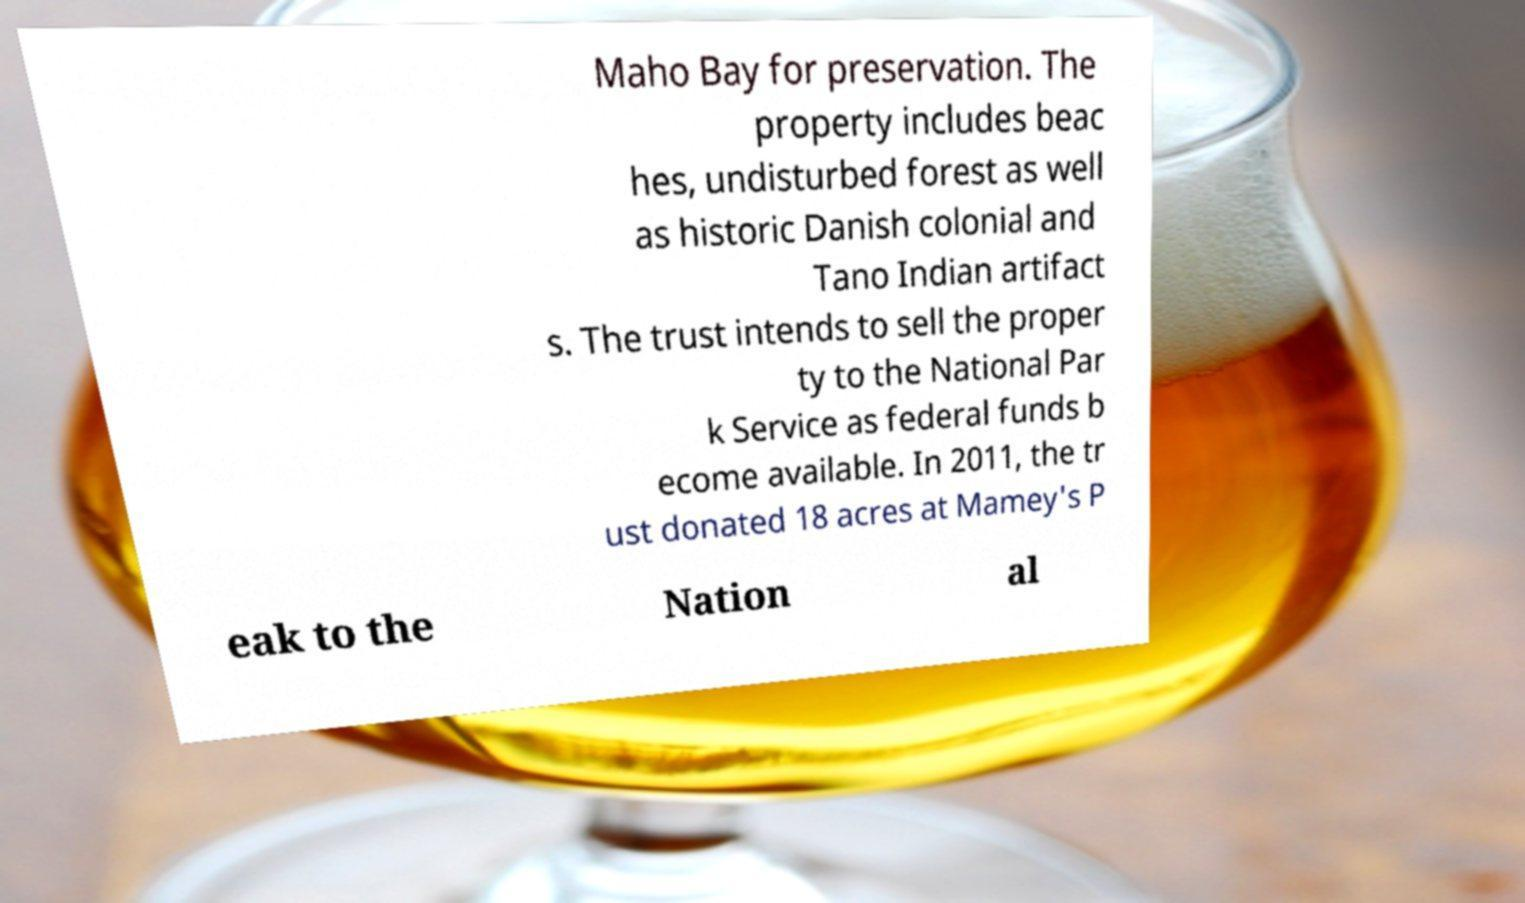For documentation purposes, I need the text within this image transcribed. Could you provide that? Maho Bay for preservation. The property includes beac hes, undisturbed forest as well as historic Danish colonial and Tano Indian artifact s. The trust intends to sell the proper ty to the National Par k Service as federal funds b ecome available. In 2011, the tr ust donated 18 acres at Mamey's P eak to the Nation al 